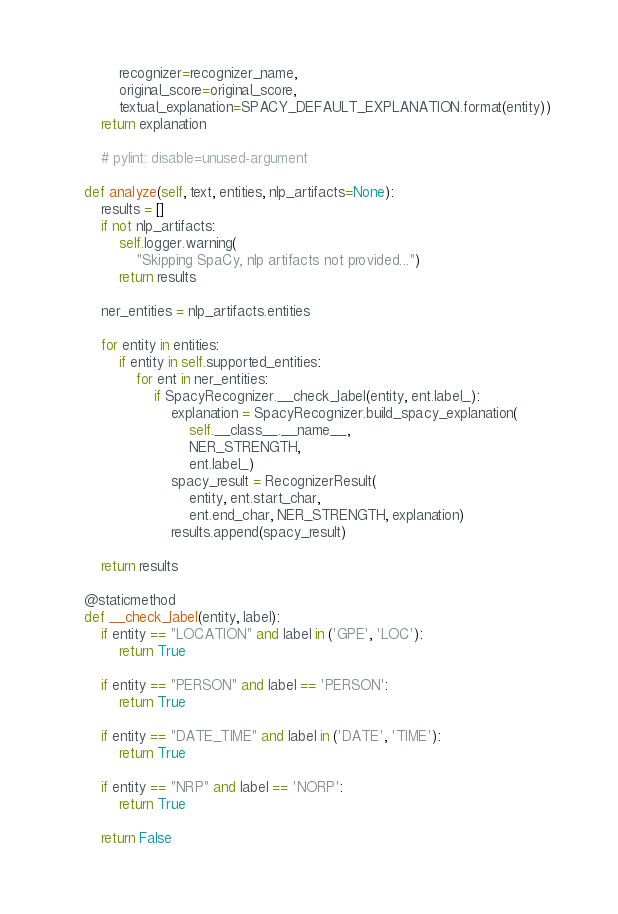Convert code to text. <code><loc_0><loc_0><loc_500><loc_500><_Python_>            recognizer=recognizer_name,
            original_score=original_score,
            textual_explanation=SPACY_DEFAULT_EXPLANATION.format(entity))
        return explanation

        # pylint: disable=unused-argument

    def analyze(self, text, entities, nlp_artifacts=None):
        results = []
        if not nlp_artifacts:
            self.logger.warning(
                "Skipping SpaCy, nlp artifacts not provided...")
            return results

        ner_entities = nlp_artifacts.entities

        for entity in entities:
            if entity in self.supported_entities:
                for ent in ner_entities:
                    if SpacyRecognizer.__check_label(entity, ent.label_):
                        explanation = SpacyRecognizer.build_spacy_explanation(
                            self.__class__.__name__,
                            NER_STRENGTH,
                            ent.label_)
                        spacy_result = RecognizerResult(
                            entity, ent.start_char,
                            ent.end_char, NER_STRENGTH, explanation)
                        results.append(spacy_result)

        return results

    @staticmethod
    def __check_label(entity, label):
        if entity == "LOCATION" and label in ('GPE', 'LOC'):
            return True

        if entity == "PERSON" and label == 'PERSON':
            return True

        if entity == "DATE_TIME" and label in ('DATE', 'TIME'):
            return True

        if entity == "NRP" and label == 'NORP':
            return True

        return False
</code> 